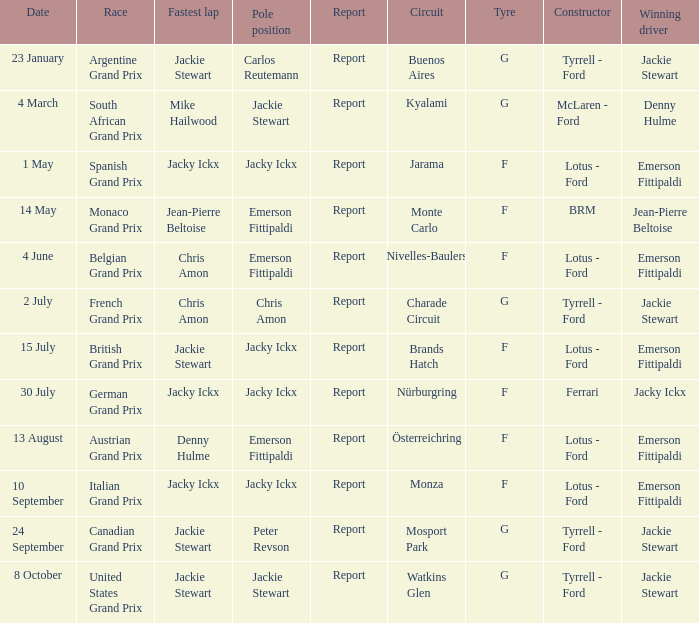What circuit was the British Grand Prix? Brands Hatch. 